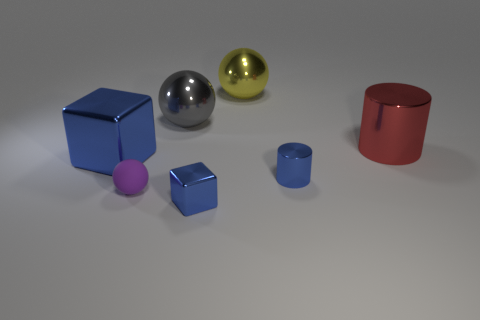What color is the metal thing that is right of the yellow metallic object and in front of the red object?
Your answer should be compact. Blue. Are the large thing in front of the big cylinder and the cylinder that is behind the small blue shiny cylinder made of the same material?
Make the answer very short. Yes. Are there more big yellow shiny spheres that are on the right side of the blue metal cylinder than blue cubes right of the big gray ball?
Your answer should be compact. No. There is a yellow shiny object that is the same size as the red thing; what is its shape?
Give a very brief answer. Sphere. What number of objects are large yellow shiny balls or metal cubes left of the big gray thing?
Provide a succinct answer. 2. Is the tiny rubber sphere the same color as the small shiny block?
Give a very brief answer. No. There is a blue metallic cylinder; what number of things are behind it?
Keep it short and to the point. 4. There is a small thing that is made of the same material as the tiny blue cylinder; what color is it?
Offer a terse response. Blue. How many shiny objects are either brown objects or large objects?
Keep it short and to the point. 4. Does the tiny purple ball have the same material as the tiny blue cylinder?
Give a very brief answer. No. 